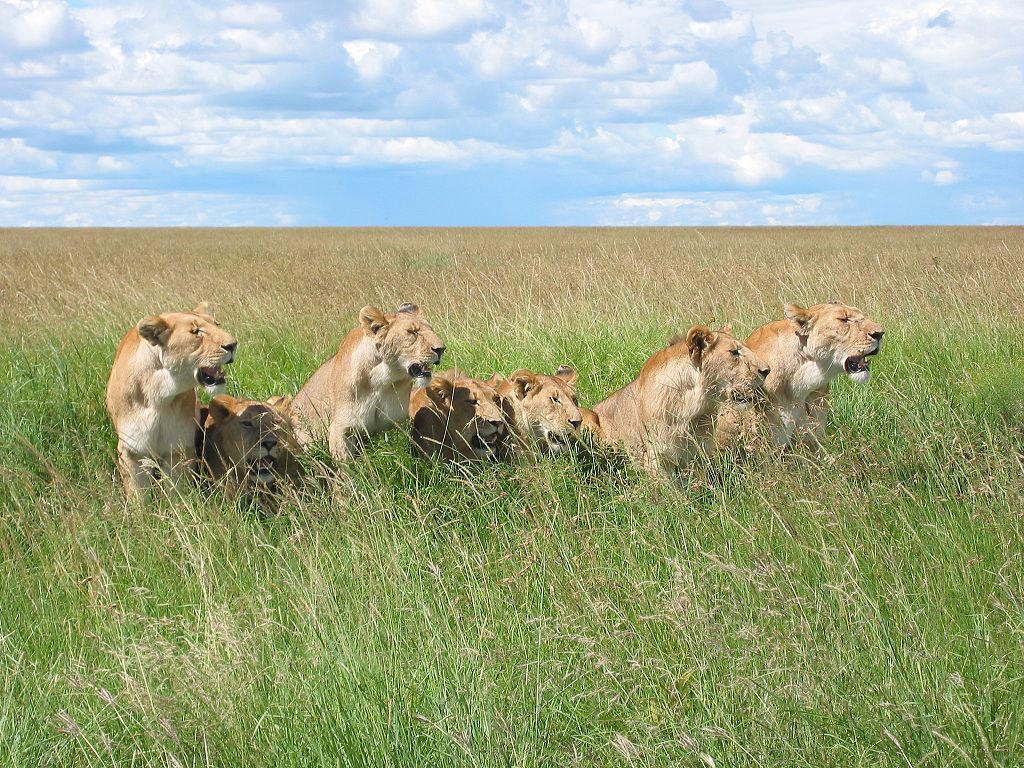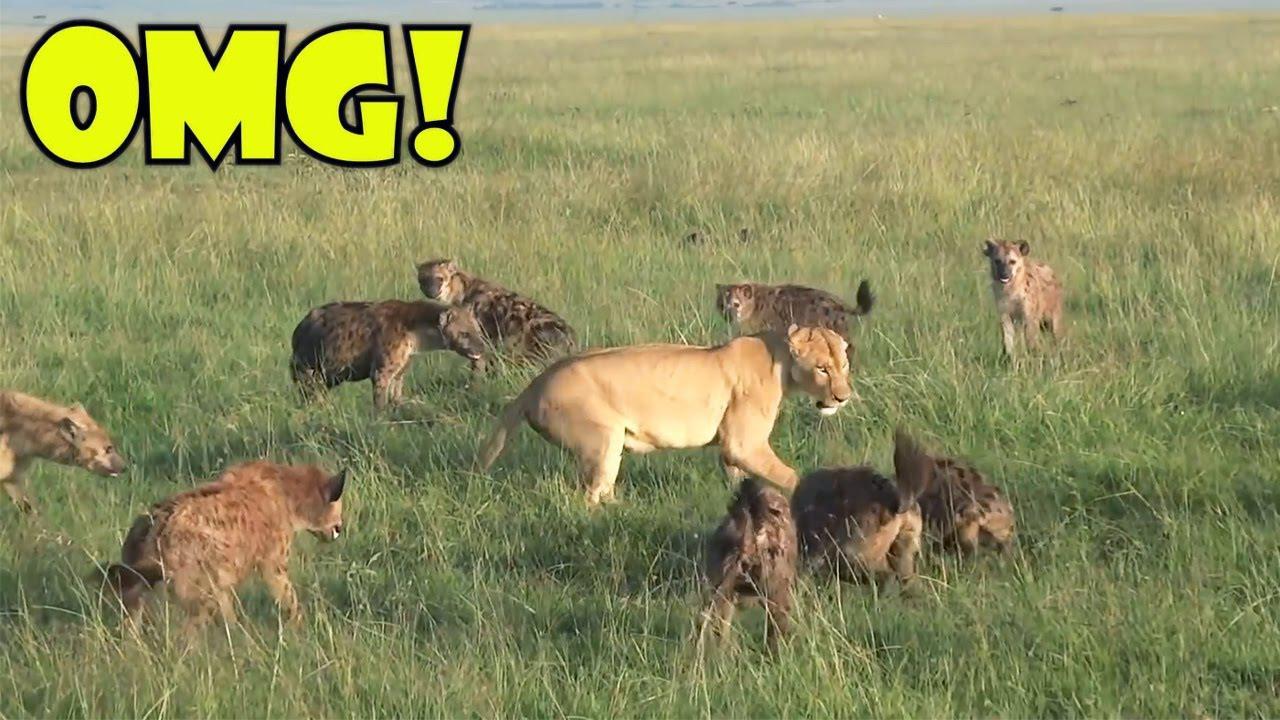The first image is the image on the left, the second image is the image on the right. Considering the images on both sides, is "The image on the right shows no more than 5 cats." valid? Answer yes or no. No. 